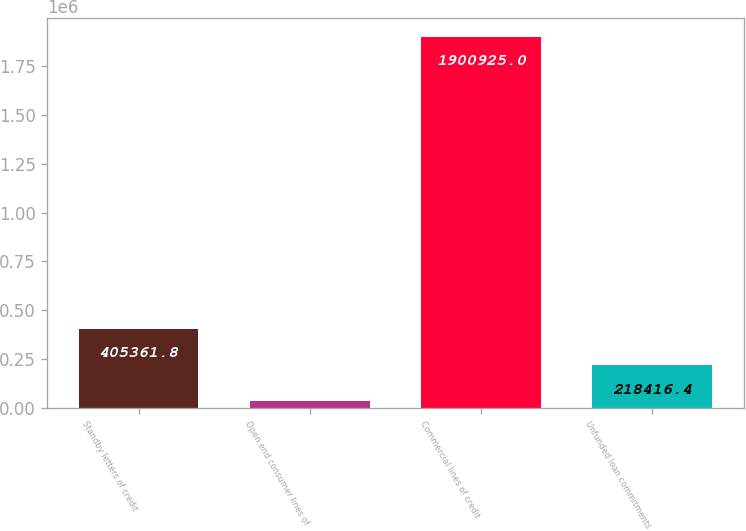<chart> <loc_0><loc_0><loc_500><loc_500><bar_chart><fcel>Standby letters of credit<fcel>Open end consumer lines of<fcel>Commercial lines of credit<fcel>Unfunded loan commitments<nl><fcel>405362<fcel>31471<fcel>1.90092e+06<fcel>218416<nl></chart> 